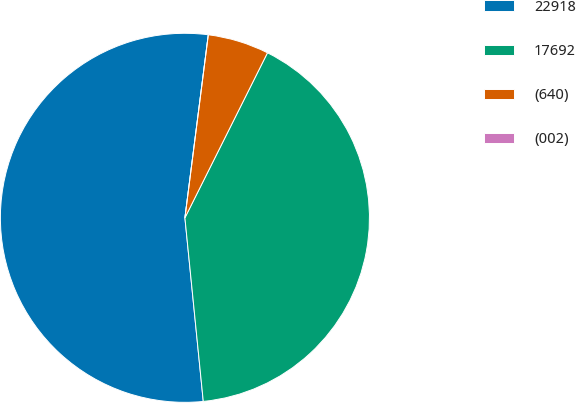Convert chart to OTSL. <chart><loc_0><loc_0><loc_500><loc_500><pie_chart><fcel>22918<fcel>17692<fcel>(640)<fcel>(002)<nl><fcel>53.61%<fcel>41.03%<fcel>5.36%<fcel>0.0%<nl></chart> 